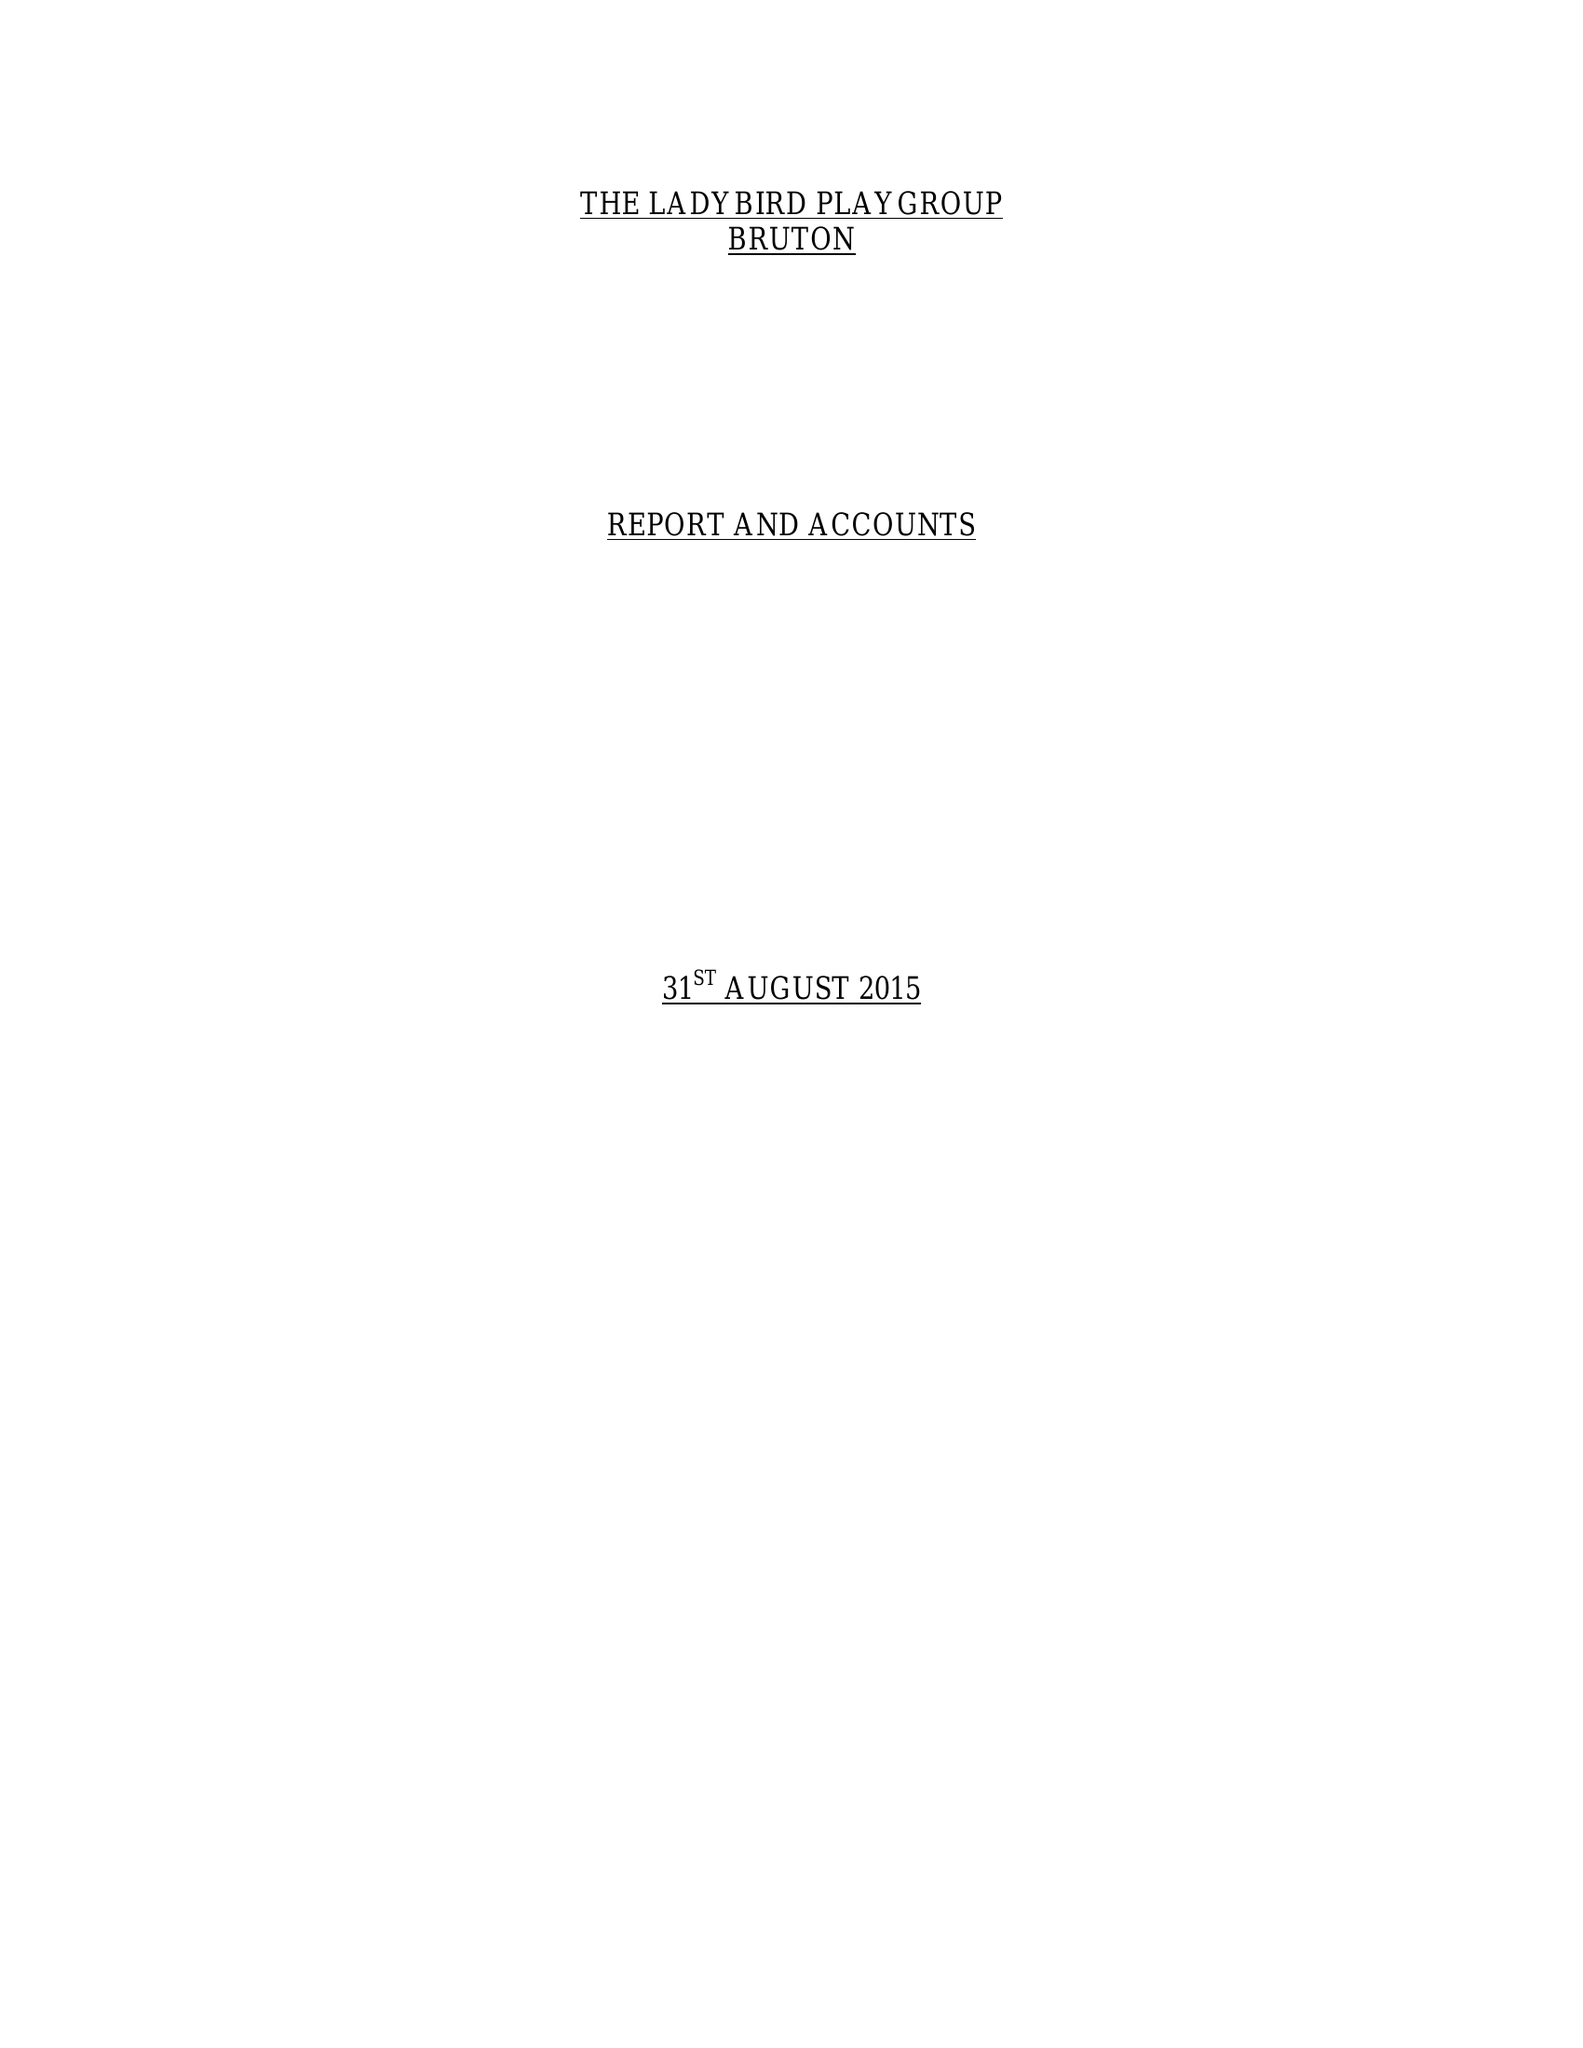What is the value for the report_date?
Answer the question using a single word or phrase. 2015-08-31 